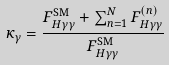Convert formula to latex. <formula><loc_0><loc_0><loc_500><loc_500>\kappa _ { \gamma } = \frac { F _ { H \gamma \gamma } ^ { \text {SM} } + \sum _ { n = 1 } ^ { N } F _ { H \gamma \gamma } ^ { ( n ) } } { F _ { H \gamma \gamma } ^ { \text {SM} } }</formula> 